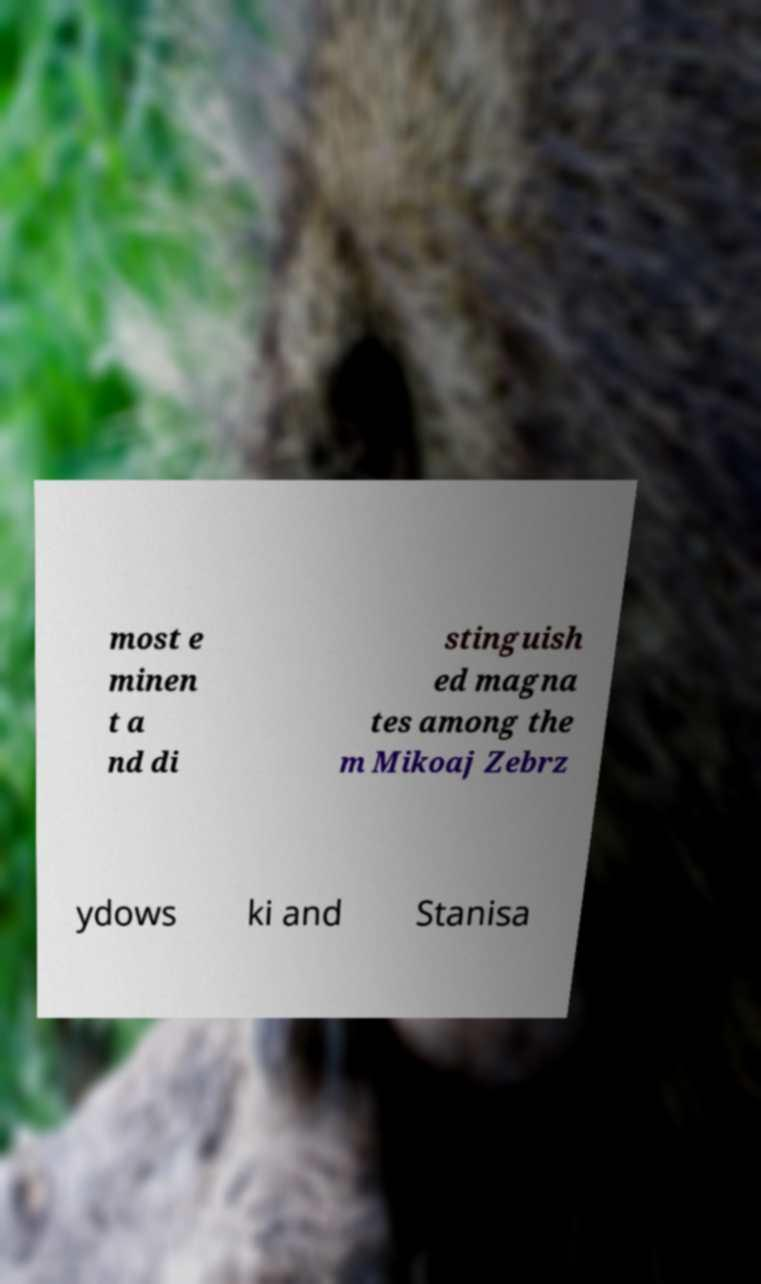Please read and relay the text visible in this image. What does it say? most e minen t a nd di stinguish ed magna tes among the m Mikoaj Zebrz ydows ki and Stanisa 